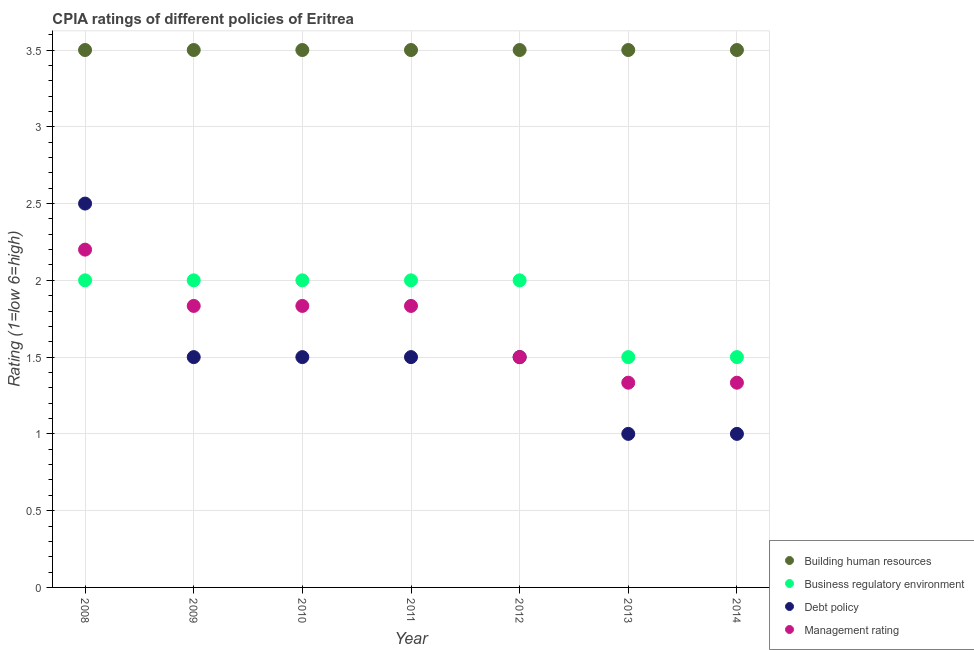Is the number of dotlines equal to the number of legend labels?
Offer a very short reply. Yes. Across all years, what is the maximum cpia rating of management?
Keep it short and to the point. 2.2. Across all years, what is the minimum cpia rating of business regulatory environment?
Your answer should be compact. 1.5. In which year was the cpia rating of building human resources minimum?
Your answer should be compact. 2008. What is the total cpia rating of building human resources in the graph?
Give a very brief answer. 24.5. What is the difference between the cpia rating of management in 2008 and that in 2011?
Give a very brief answer. 0.37. What is the average cpia rating of management per year?
Give a very brief answer. 1.7. In the year 2008, what is the difference between the cpia rating of building human resources and cpia rating of management?
Offer a terse response. 1.3. What is the ratio of the cpia rating of debt policy in 2008 to that in 2010?
Offer a terse response. 1.67. Is the difference between the cpia rating of business regulatory environment in 2012 and 2014 greater than the difference between the cpia rating of debt policy in 2012 and 2014?
Your answer should be compact. No. What is the difference between the highest and the lowest cpia rating of business regulatory environment?
Offer a terse response. 0.5. Is the sum of the cpia rating of management in 2010 and 2013 greater than the maximum cpia rating of business regulatory environment across all years?
Give a very brief answer. Yes. Is it the case that in every year, the sum of the cpia rating of building human resources and cpia rating of business regulatory environment is greater than the cpia rating of debt policy?
Your answer should be very brief. Yes. Is the cpia rating of debt policy strictly greater than the cpia rating of building human resources over the years?
Make the answer very short. No. Is the cpia rating of debt policy strictly less than the cpia rating of building human resources over the years?
Keep it short and to the point. Yes. How many dotlines are there?
Your answer should be very brief. 4. How many years are there in the graph?
Provide a short and direct response. 7. What is the difference between two consecutive major ticks on the Y-axis?
Offer a very short reply. 0.5. Are the values on the major ticks of Y-axis written in scientific E-notation?
Ensure brevity in your answer.  No. Where does the legend appear in the graph?
Offer a terse response. Bottom right. How are the legend labels stacked?
Offer a very short reply. Vertical. What is the title of the graph?
Give a very brief answer. CPIA ratings of different policies of Eritrea. Does "Pre-primary schools" appear as one of the legend labels in the graph?
Offer a terse response. No. What is the label or title of the X-axis?
Your answer should be compact. Year. What is the label or title of the Y-axis?
Your answer should be compact. Rating (1=low 6=high). What is the Rating (1=low 6=high) in Business regulatory environment in 2008?
Keep it short and to the point. 2. What is the Rating (1=low 6=high) in Debt policy in 2008?
Keep it short and to the point. 2.5. What is the Rating (1=low 6=high) in Management rating in 2008?
Keep it short and to the point. 2.2. What is the Rating (1=low 6=high) in Building human resources in 2009?
Offer a terse response. 3.5. What is the Rating (1=low 6=high) of Business regulatory environment in 2009?
Offer a terse response. 2. What is the Rating (1=low 6=high) in Management rating in 2009?
Provide a short and direct response. 1.83. What is the Rating (1=low 6=high) of Management rating in 2010?
Your answer should be compact. 1.83. What is the Rating (1=low 6=high) of Building human resources in 2011?
Your answer should be compact. 3.5. What is the Rating (1=low 6=high) in Management rating in 2011?
Make the answer very short. 1.83. What is the Rating (1=low 6=high) of Business regulatory environment in 2012?
Offer a very short reply. 2. What is the Rating (1=low 6=high) of Business regulatory environment in 2013?
Your answer should be compact. 1.5. What is the Rating (1=low 6=high) of Debt policy in 2013?
Your response must be concise. 1. What is the Rating (1=low 6=high) in Management rating in 2013?
Offer a terse response. 1.33. What is the Rating (1=low 6=high) of Debt policy in 2014?
Your response must be concise. 1. What is the Rating (1=low 6=high) in Management rating in 2014?
Your response must be concise. 1.33. Across all years, what is the maximum Rating (1=low 6=high) of Debt policy?
Keep it short and to the point. 2.5. Across all years, what is the minimum Rating (1=low 6=high) in Building human resources?
Your answer should be compact. 3.5. Across all years, what is the minimum Rating (1=low 6=high) of Business regulatory environment?
Provide a short and direct response. 1.5. Across all years, what is the minimum Rating (1=low 6=high) of Debt policy?
Provide a short and direct response. 1. Across all years, what is the minimum Rating (1=low 6=high) of Management rating?
Your response must be concise. 1.33. What is the total Rating (1=low 6=high) in Building human resources in the graph?
Keep it short and to the point. 24.5. What is the total Rating (1=low 6=high) of Debt policy in the graph?
Offer a very short reply. 10.5. What is the total Rating (1=low 6=high) in Management rating in the graph?
Your answer should be very brief. 11.87. What is the difference between the Rating (1=low 6=high) of Debt policy in 2008 and that in 2009?
Your answer should be compact. 1. What is the difference between the Rating (1=low 6=high) in Management rating in 2008 and that in 2009?
Offer a terse response. 0.37. What is the difference between the Rating (1=low 6=high) of Building human resources in 2008 and that in 2010?
Make the answer very short. 0. What is the difference between the Rating (1=low 6=high) in Debt policy in 2008 and that in 2010?
Your answer should be compact. 1. What is the difference between the Rating (1=low 6=high) of Management rating in 2008 and that in 2010?
Your response must be concise. 0.37. What is the difference between the Rating (1=low 6=high) in Building human resources in 2008 and that in 2011?
Offer a very short reply. 0. What is the difference between the Rating (1=low 6=high) of Management rating in 2008 and that in 2011?
Your response must be concise. 0.37. What is the difference between the Rating (1=low 6=high) of Building human resources in 2008 and that in 2012?
Your answer should be very brief. 0. What is the difference between the Rating (1=low 6=high) in Building human resources in 2008 and that in 2013?
Give a very brief answer. 0. What is the difference between the Rating (1=low 6=high) of Management rating in 2008 and that in 2013?
Offer a very short reply. 0.87. What is the difference between the Rating (1=low 6=high) of Building human resources in 2008 and that in 2014?
Make the answer very short. 0. What is the difference between the Rating (1=low 6=high) in Business regulatory environment in 2008 and that in 2014?
Provide a short and direct response. 0.5. What is the difference between the Rating (1=low 6=high) in Management rating in 2008 and that in 2014?
Your response must be concise. 0.87. What is the difference between the Rating (1=low 6=high) of Building human resources in 2009 and that in 2010?
Ensure brevity in your answer.  0. What is the difference between the Rating (1=low 6=high) in Business regulatory environment in 2009 and that in 2010?
Provide a short and direct response. 0. What is the difference between the Rating (1=low 6=high) of Management rating in 2009 and that in 2010?
Provide a short and direct response. 0. What is the difference between the Rating (1=low 6=high) of Management rating in 2009 and that in 2011?
Your answer should be very brief. 0. What is the difference between the Rating (1=low 6=high) in Debt policy in 2009 and that in 2012?
Offer a terse response. 0. What is the difference between the Rating (1=low 6=high) in Building human resources in 2009 and that in 2013?
Offer a very short reply. 0. What is the difference between the Rating (1=low 6=high) of Management rating in 2009 and that in 2013?
Give a very brief answer. 0.5. What is the difference between the Rating (1=low 6=high) in Building human resources in 2009 and that in 2014?
Give a very brief answer. 0. What is the difference between the Rating (1=low 6=high) of Business regulatory environment in 2009 and that in 2014?
Your answer should be compact. 0.5. What is the difference between the Rating (1=low 6=high) of Management rating in 2009 and that in 2014?
Provide a short and direct response. 0.5. What is the difference between the Rating (1=low 6=high) of Business regulatory environment in 2010 and that in 2011?
Make the answer very short. 0. What is the difference between the Rating (1=low 6=high) in Building human resources in 2010 and that in 2012?
Ensure brevity in your answer.  0. What is the difference between the Rating (1=low 6=high) in Business regulatory environment in 2010 and that in 2012?
Keep it short and to the point. 0. What is the difference between the Rating (1=low 6=high) of Management rating in 2010 and that in 2012?
Offer a terse response. 0.33. What is the difference between the Rating (1=low 6=high) of Building human resources in 2010 and that in 2013?
Offer a terse response. 0. What is the difference between the Rating (1=low 6=high) of Debt policy in 2010 and that in 2013?
Provide a short and direct response. 0.5. What is the difference between the Rating (1=low 6=high) of Management rating in 2010 and that in 2013?
Offer a very short reply. 0.5. What is the difference between the Rating (1=low 6=high) in Management rating in 2010 and that in 2014?
Provide a short and direct response. 0.5. What is the difference between the Rating (1=low 6=high) in Building human resources in 2011 and that in 2012?
Your answer should be compact. 0. What is the difference between the Rating (1=low 6=high) of Management rating in 2011 and that in 2013?
Offer a very short reply. 0.5. What is the difference between the Rating (1=low 6=high) in Business regulatory environment in 2011 and that in 2014?
Ensure brevity in your answer.  0.5. What is the difference between the Rating (1=low 6=high) in Management rating in 2011 and that in 2014?
Your answer should be compact. 0.5. What is the difference between the Rating (1=low 6=high) of Business regulatory environment in 2012 and that in 2013?
Provide a succinct answer. 0.5. What is the difference between the Rating (1=low 6=high) of Debt policy in 2012 and that in 2013?
Your answer should be very brief. 0.5. What is the difference between the Rating (1=low 6=high) in Building human resources in 2012 and that in 2014?
Your answer should be very brief. 0. What is the difference between the Rating (1=low 6=high) of Business regulatory environment in 2012 and that in 2014?
Ensure brevity in your answer.  0.5. What is the difference between the Rating (1=low 6=high) in Debt policy in 2012 and that in 2014?
Provide a short and direct response. 0.5. What is the difference between the Rating (1=low 6=high) in Management rating in 2012 and that in 2014?
Provide a short and direct response. 0.17. What is the difference between the Rating (1=low 6=high) in Business regulatory environment in 2013 and that in 2014?
Your response must be concise. 0. What is the difference between the Rating (1=low 6=high) in Building human resources in 2008 and the Rating (1=low 6=high) in Business regulatory environment in 2009?
Give a very brief answer. 1.5. What is the difference between the Rating (1=low 6=high) of Building human resources in 2008 and the Rating (1=low 6=high) of Management rating in 2009?
Keep it short and to the point. 1.67. What is the difference between the Rating (1=low 6=high) of Business regulatory environment in 2008 and the Rating (1=low 6=high) of Debt policy in 2009?
Make the answer very short. 0.5. What is the difference between the Rating (1=low 6=high) of Building human resources in 2008 and the Rating (1=low 6=high) of Business regulatory environment in 2010?
Provide a short and direct response. 1.5. What is the difference between the Rating (1=low 6=high) of Business regulatory environment in 2008 and the Rating (1=low 6=high) of Debt policy in 2010?
Keep it short and to the point. 0.5. What is the difference between the Rating (1=low 6=high) of Business regulatory environment in 2008 and the Rating (1=low 6=high) of Management rating in 2010?
Make the answer very short. 0.17. What is the difference between the Rating (1=low 6=high) in Debt policy in 2008 and the Rating (1=low 6=high) in Management rating in 2010?
Keep it short and to the point. 0.67. What is the difference between the Rating (1=low 6=high) of Building human resources in 2008 and the Rating (1=low 6=high) of Debt policy in 2011?
Your answer should be compact. 2. What is the difference between the Rating (1=low 6=high) of Building human resources in 2008 and the Rating (1=low 6=high) of Management rating in 2011?
Keep it short and to the point. 1.67. What is the difference between the Rating (1=low 6=high) in Business regulatory environment in 2008 and the Rating (1=low 6=high) in Debt policy in 2011?
Offer a very short reply. 0.5. What is the difference between the Rating (1=low 6=high) of Business regulatory environment in 2008 and the Rating (1=low 6=high) of Management rating in 2011?
Ensure brevity in your answer.  0.17. What is the difference between the Rating (1=low 6=high) in Building human resources in 2008 and the Rating (1=low 6=high) in Business regulatory environment in 2012?
Offer a terse response. 1.5. What is the difference between the Rating (1=low 6=high) in Building human resources in 2008 and the Rating (1=low 6=high) in Debt policy in 2012?
Ensure brevity in your answer.  2. What is the difference between the Rating (1=low 6=high) of Building human resources in 2008 and the Rating (1=low 6=high) of Management rating in 2012?
Your response must be concise. 2. What is the difference between the Rating (1=low 6=high) in Business regulatory environment in 2008 and the Rating (1=low 6=high) in Debt policy in 2012?
Keep it short and to the point. 0.5. What is the difference between the Rating (1=low 6=high) of Building human resources in 2008 and the Rating (1=low 6=high) of Business regulatory environment in 2013?
Provide a short and direct response. 2. What is the difference between the Rating (1=low 6=high) of Building human resources in 2008 and the Rating (1=low 6=high) of Debt policy in 2013?
Provide a succinct answer. 2.5. What is the difference between the Rating (1=low 6=high) in Building human resources in 2008 and the Rating (1=low 6=high) in Management rating in 2013?
Offer a terse response. 2.17. What is the difference between the Rating (1=low 6=high) of Building human resources in 2008 and the Rating (1=low 6=high) of Debt policy in 2014?
Your answer should be very brief. 2.5. What is the difference between the Rating (1=low 6=high) of Building human resources in 2008 and the Rating (1=low 6=high) of Management rating in 2014?
Your answer should be very brief. 2.17. What is the difference between the Rating (1=low 6=high) in Debt policy in 2008 and the Rating (1=low 6=high) in Management rating in 2014?
Your answer should be very brief. 1.17. What is the difference between the Rating (1=low 6=high) of Building human resources in 2009 and the Rating (1=low 6=high) of Business regulatory environment in 2010?
Provide a short and direct response. 1.5. What is the difference between the Rating (1=low 6=high) in Building human resources in 2009 and the Rating (1=low 6=high) in Debt policy in 2010?
Give a very brief answer. 2. What is the difference between the Rating (1=low 6=high) of Building human resources in 2009 and the Rating (1=low 6=high) of Management rating in 2010?
Provide a short and direct response. 1.67. What is the difference between the Rating (1=low 6=high) of Business regulatory environment in 2009 and the Rating (1=low 6=high) of Debt policy in 2010?
Your response must be concise. 0.5. What is the difference between the Rating (1=low 6=high) of Business regulatory environment in 2009 and the Rating (1=low 6=high) of Management rating in 2010?
Provide a short and direct response. 0.17. What is the difference between the Rating (1=low 6=high) in Debt policy in 2009 and the Rating (1=low 6=high) in Management rating in 2010?
Offer a terse response. -0.33. What is the difference between the Rating (1=low 6=high) of Building human resources in 2009 and the Rating (1=low 6=high) of Debt policy in 2011?
Ensure brevity in your answer.  2. What is the difference between the Rating (1=low 6=high) in Building human resources in 2009 and the Rating (1=low 6=high) in Management rating in 2011?
Provide a short and direct response. 1.67. What is the difference between the Rating (1=low 6=high) in Debt policy in 2009 and the Rating (1=low 6=high) in Management rating in 2011?
Your answer should be very brief. -0.33. What is the difference between the Rating (1=low 6=high) in Building human resources in 2009 and the Rating (1=low 6=high) in Business regulatory environment in 2012?
Ensure brevity in your answer.  1.5. What is the difference between the Rating (1=low 6=high) in Business regulatory environment in 2009 and the Rating (1=low 6=high) in Management rating in 2012?
Offer a very short reply. 0.5. What is the difference between the Rating (1=low 6=high) of Debt policy in 2009 and the Rating (1=low 6=high) of Management rating in 2012?
Make the answer very short. 0. What is the difference between the Rating (1=low 6=high) of Building human resources in 2009 and the Rating (1=low 6=high) of Management rating in 2013?
Provide a short and direct response. 2.17. What is the difference between the Rating (1=low 6=high) in Business regulatory environment in 2009 and the Rating (1=low 6=high) in Debt policy in 2013?
Provide a succinct answer. 1. What is the difference between the Rating (1=low 6=high) in Business regulatory environment in 2009 and the Rating (1=low 6=high) in Management rating in 2013?
Give a very brief answer. 0.67. What is the difference between the Rating (1=low 6=high) in Debt policy in 2009 and the Rating (1=low 6=high) in Management rating in 2013?
Give a very brief answer. 0.17. What is the difference between the Rating (1=low 6=high) of Building human resources in 2009 and the Rating (1=low 6=high) of Business regulatory environment in 2014?
Your answer should be very brief. 2. What is the difference between the Rating (1=low 6=high) in Building human resources in 2009 and the Rating (1=low 6=high) in Debt policy in 2014?
Keep it short and to the point. 2.5. What is the difference between the Rating (1=low 6=high) in Building human resources in 2009 and the Rating (1=low 6=high) in Management rating in 2014?
Make the answer very short. 2.17. What is the difference between the Rating (1=low 6=high) in Building human resources in 2010 and the Rating (1=low 6=high) in Business regulatory environment in 2011?
Make the answer very short. 1.5. What is the difference between the Rating (1=low 6=high) of Business regulatory environment in 2010 and the Rating (1=low 6=high) of Debt policy in 2011?
Offer a terse response. 0.5. What is the difference between the Rating (1=low 6=high) in Building human resources in 2010 and the Rating (1=low 6=high) in Debt policy in 2012?
Your response must be concise. 2. What is the difference between the Rating (1=low 6=high) of Business regulatory environment in 2010 and the Rating (1=low 6=high) of Management rating in 2012?
Give a very brief answer. 0.5. What is the difference between the Rating (1=low 6=high) in Debt policy in 2010 and the Rating (1=low 6=high) in Management rating in 2012?
Give a very brief answer. 0. What is the difference between the Rating (1=low 6=high) in Building human resources in 2010 and the Rating (1=low 6=high) in Business regulatory environment in 2013?
Give a very brief answer. 2. What is the difference between the Rating (1=low 6=high) in Building human resources in 2010 and the Rating (1=low 6=high) in Management rating in 2013?
Provide a succinct answer. 2.17. What is the difference between the Rating (1=low 6=high) of Business regulatory environment in 2010 and the Rating (1=low 6=high) of Management rating in 2013?
Provide a succinct answer. 0.67. What is the difference between the Rating (1=low 6=high) of Building human resources in 2010 and the Rating (1=low 6=high) of Debt policy in 2014?
Your answer should be compact. 2.5. What is the difference between the Rating (1=low 6=high) in Building human resources in 2010 and the Rating (1=low 6=high) in Management rating in 2014?
Your answer should be very brief. 2.17. What is the difference between the Rating (1=low 6=high) in Building human resources in 2011 and the Rating (1=low 6=high) in Debt policy in 2012?
Offer a terse response. 2. What is the difference between the Rating (1=low 6=high) in Debt policy in 2011 and the Rating (1=low 6=high) in Management rating in 2012?
Offer a very short reply. 0. What is the difference between the Rating (1=low 6=high) in Building human resources in 2011 and the Rating (1=low 6=high) in Management rating in 2013?
Keep it short and to the point. 2.17. What is the difference between the Rating (1=low 6=high) of Business regulatory environment in 2011 and the Rating (1=low 6=high) of Debt policy in 2013?
Give a very brief answer. 1. What is the difference between the Rating (1=low 6=high) of Debt policy in 2011 and the Rating (1=low 6=high) of Management rating in 2013?
Keep it short and to the point. 0.17. What is the difference between the Rating (1=low 6=high) in Building human resources in 2011 and the Rating (1=low 6=high) in Business regulatory environment in 2014?
Ensure brevity in your answer.  2. What is the difference between the Rating (1=low 6=high) in Building human resources in 2011 and the Rating (1=low 6=high) in Debt policy in 2014?
Provide a succinct answer. 2.5. What is the difference between the Rating (1=low 6=high) in Building human resources in 2011 and the Rating (1=low 6=high) in Management rating in 2014?
Provide a succinct answer. 2.17. What is the difference between the Rating (1=low 6=high) of Debt policy in 2011 and the Rating (1=low 6=high) of Management rating in 2014?
Your answer should be very brief. 0.17. What is the difference between the Rating (1=low 6=high) of Building human resources in 2012 and the Rating (1=low 6=high) of Management rating in 2013?
Offer a very short reply. 2.17. What is the difference between the Rating (1=low 6=high) of Business regulatory environment in 2012 and the Rating (1=low 6=high) of Debt policy in 2013?
Give a very brief answer. 1. What is the difference between the Rating (1=low 6=high) in Business regulatory environment in 2012 and the Rating (1=low 6=high) in Management rating in 2013?
Keep it short and to the point. 0.67. What is the difference between the Rating (1=low 6=high) of Debt policy in 2012 and the Rating (1=low 6=high) of Management rating in 2013?
Your answer should be compact. 0.17. What is the difference between the Rating (1=low 6=high) in Building human resources in 2012 and the Rating (1=low 6=high) in Business regulatory environment in 2014?
Your answer should be very brief. 2. What is the difference between the Rating (1=low 6=high) of Building human resources in 2012 and the Rating (1=low 6=high) of Debt policy in 2014?
Offer a very short reply. 2.5. What is the difference between the Rating (1=low 6=high) in Building human resources in 2012 and the Rating (1=low 6=high) in Management rating in 2014?
Keep it short and to the point. 2.17. What is the difference between the Rating (1=low 6=high) of Debt policy in 2012 and the Rating (1=low 6=high) of Management rating in 2014?
Provide a succinct answer. 0.17. What is the difference between the Rating (1=low 6=high) of Building human resources in 2013 and the Rating (1=low 6=high) of Debt policy in 2014?
Your response must be concise. 2.5. What is the difference between the Rating (1=low 6=high) in Building human resources in 2013 and the Rating (1=low 6=high) in Management rating in 2014?
Your answer should be very brief. 2.17. What is the average Rating (1=low 6=high) of Building human resources per year?
Provide a succinct answer. 3.5. What is the average Rating (1=low 6=high) of Business regulatory environment per year?
Your answer should be very brief. 1.86. What is the average Rating (1=low 6=high) of Management rating per year?
Offer a very short reply. 1.7. In the year 2008, what is the difference between the Rating (1=low 6=high) of Building human resources and Rating (1=low 6=high) of Business regulatory environment?
Provide a succinct answer. 1.5. In the year 2008, what is the difference between the Rating (1=low 6=high) in Building human resources and Rating (1=low 6=high) in Management rating?
Ensure brevity in your answer.  1.3. In the year 2008, what is the difference between the Rating (1=low 6=high) in Business regulatory environment and Rating (1=low 6=high) in Debt policy?
Offer a very short reply. -0.5. In the year 2008, what is the difference between the Rating (1=low 6=high) in Debt policy and Rating (1=low 6=high) in Management rating?
Your answer should be very brief. 0.3. In the year 2009, what is the difference between the Rating (1=low 6=high) of Building human resources and Rating (1=low 6=high) of Debt policy?
Provide a short and direct response. 2. In the year 2009, what is the difference between the Rating (1=low 6=high) of Business regulatory environment and Rating (1=low 6=high) of Management rating?
Ensure brevity in your answer.  0.17. In the year 2010, what is the difference between the Rating (1=low 6=high) in Business regulatory environment and Rating (1=low 6=high) in Management rating?
Your answer should be very brief. 0.17. In the year 2011, what is the difference between the Rating (1=low 6=high) in Building human resources and Rating (1=low 6=high) in Debt policy?
Your answer should be very brief. 2. In the year 2011, what is the difference between the Rating (1=low 6=high) in Business regulatory environment and Rating (1=low 6=high) in Debt policy?
Provide a short and direct response. 0.5. In the year 2011, what is the difference between the Rating (1=low 6=high) in Business regulatory environment and Rating (1=low 6=high) in Management rating?
Keep it short and to the point. 0.17. In the year 2011, what is the difference between the Rating (1=low 6=high) in Debt policy and Rating (1=low 6=high) in Management rating?
Offer a very short reply. -0.33. In the year 2013, what is the difference between the Rating (1=low 6=high) in Building human resources and Rating (1=low 6=high) in Debt policy?
Your answer should be very brief. 2.5. In the year 2013, what is the difference between the Rating (1=low 6=high) in Building human resources and Rating (1=low 6=high) in Management rating?
Offer a terse response. 2.17. In the year 2013, what is the difference between the Rating (1=low 6=high) in Business regulatory environment and Rating (1=low 6=high) in Debt policy?
Offer a terse response. 0.5. In the year 2013, what is the difference between the Rating (1=low 6=high) in Debt policy and Rating (1=low 6=high) in Management rating?
Keep it short and to the point. -0.33. In the year 2014, what is the difference between the Rating (1=low 6=high) of Building human resources and Rating (1=low 6=high) of Business regulatory environment?
Your response must be concise. 2. In the year 2014, what is the difference between the Rating (1=low 6=high) in Building human resources and Rating (1=low 6=high) in Management rating?
Your answer should be compact. 2.17. In the year 2014, what is the difference between the Rating (1=low 6=high) of Business regulatory environment and Rating (1=low 6=high) of Management rating?
Provide a succinct answer. 0.17. What is the ratio of the Rating (1=low 6=high) of Debt policy in 2008 to that in 2009?
Ensure brevity in your answer.  1.67. What is the ratio of the Rating (1=low 6=high) in Building human resources in 2008 to that in 2010?
Offer a very short reply. 1. What is the ratio of the Rating (1=low 6=high) in Business regulatory environment in 2008 to that in 2010?
Make the answer very short. 1. What is the ratio of the Rating (1=low 6=high) in Debt policy in 2008 to that in 2010?
Give a very brief answer. 1.67. What is the ratio of the Rating (1=low 6=high) of Debt policy in 2008 to that in 2011?
Ensure brevity in your answer.  1.67. What is the ratio of the Rating (1=low 6=high) of Management rating in 2008 to that in 2012?
Keep it short and to the point. 1.47. What is the ratio of the Rating (1=low 6=high) in Business regulatory environment in 2008 to that in 2013?
Offer a very short reply. 1.33. What is the ratio of the Rating (1=low 6=high) of Debt policy in 2008 to that in 2013?
Offer a very short reply. 2.5. What is the ratio of the Rating (1=low 6=high) in Management rating in 2008 to that in 2013?
Offer a terse response. 1.65. What is the ratio of the Rating (1=low 6=high) in Business regulatory environment in 2008 to that in 2014?
Your response must be concise. 1.33. What is the ratio of the Rating (1=low 6=high) of Debt policy in 2008 to that in 2014?
Provide a short and direct response. 2.5. What is the ratio of the Rating (1=low 6=high) in Management rating in 2008 to that in 2014?
Ensure brevity in your answer.  1.65. What is the ratio of the Rating (1=low 6=high) in Building human resources in 2009 to that in 2010?
Ensure brevity in your answer.  1. What is the ratio of the Rating (1=low 6=high) of Business regulatory environment in 2009 to that in 2010?
Your response must be concise. 1. What is the ratio of the Rating (1=low 6=high) in Management rating in 2009 to that in 2010?
Give a very brief answer. 1. What is the ratio of the Rating (1=low 6=high) of Business regulatory environment in 2009 to that in 2011?
Offer a very short reply. 1. What is the ratio of the Rating (1=low 6=high) in Business regulatory environment in 2009 to that in 2012?
Your response must be concise. 1. What is the ratio of the Rating (1=low 6=high) of Debt policy in 2009 to that in 2012?
Give a very brief answer. 1. What is the ratio of the Rating (1=low 6=high) in Management rating in 2009 to that in 2012?
Provide a short and direct response. 1.22. What is the ratio of the Rating (1=low 6=high) in Management rating in 2009 to that in 2013?
Your response must be concise. 1.38. What is the ratio of the Rating (1=low 6=high) in Debt policy in 2009 to that in 2014?
Provide a succinct answer. 1.5. What is the ratio of the Rating (1=low 6=high) of Management rating in 2009 to that in 2014?
Your response must be concise. 1.38. What is the ratio of the Rating (1=low 6=high) of Building human resources in 2010 to that in 2011?
Your answer should be very brief. 1. What is the ratio of the Rating (1=low 6=high) of Management rating in 2010 to that in 2011?
Provide a succinct answer. 1. What is the ratio of the Rating (1=low 6=high) of Building human resources in 2010 to that in 2012?
Ensure brevity in your answer.  1. What is the ratio of the Rating (1=low 6=high) in Business regulatory environment in 2010 to that in 2012?
Your response must be concise. 1. What is the ratio of the Rating (1=low 6=high) in Management rating in 2010 to that in 2012?
Your answer should be very brief. 1.22. What is the ratio of the Rating (1=low 6=high) in Building human resources in 2010 to that in 2013?
Make the answer very short. 1. What is the ratio of the Rating (1=low 6=high) of Management rating in 2010 to that in 2013?
Make the answer very short. 1.38. What is the ratio of the Rating (1=low 6=high) in Building human resources in 2010 to that in 2014?
Give a very brief answer. 1. What is the ratio of the Rating (1=low 6=high) of Business regulatory environment in 2010 to that in 2014?
Your answer should be very brief. 1.33. What is the ratio of the Rating (1=low 6=high) of Debt policy in 2010 to that in 2014?
Your answer should be very brief. 1.5. What is the ratio of the Rating (1=low 6=high) in Management rating in 2010 to that in 2014?
Make the answer very short. 1.38. What is the ratio of the Rating (1=low 6=high) in Business regulatory environment in 2011 to that in 2012?
Keep it short and to the point. 1. What is the ratio of the Rating (1=low 6=high) in Management rating in 2011 to that in 2012?
Give a very brief answer. 1.22. What is the ratio of the Rating (1=low 6=high) in Building human resources in 2011 to that in 2013?
Make the answer very short. 1. What is the ratio of the Rating (1=low 6=high) in Debt policy in 2011 to that in 2013?
Keep it short and to the point. 1.5. What is the ratio of the Rating (1=low 6=high) in Management rating in 2011 to that in 2013?
Ensure brevity in your answer.  1.38. What is the ratio of the Rating (1=low 6=high) in Debt policy in 2011 to that in 2014?
Make the answer very short. 1.5. What is the ratio of the Rating (1=low 6=high) of Management rating in 2011 to that in 2014?
Your answer should be very brief. 1.38. What is the ratio of the Rating (1=low 6=high) in Building human resources in 2012 to that in 2013?
Make the answer very short. 1. What is the ratio of the Rating (1=low 6=high) of Business regulatory environment in 2012 to that in 2013?
Your response must be concise. 1.33. What is the ratio of the Rating (1=low 6=high) in Debt policy in 2012 to that in 2013?
Provide a succinct answer. 1.5. What is the ratio of the Rating (1=low 6=high) in Management rating in 2012 to that in 2013?
Your response must be concise. 1.12. What is the ratio of the Rating (1=low 6=high) of Building human resources in 2012 to that in 2014?
Offer a terse response. 1. What is the ratio of the Rating (1=low 6=high) of Building human resources in 2013 to that in 2014?
Provide a succinct answer. 1. What is the ratio of the Rating (1=low 6=high) in Business regulatory environment in 2013 to that in 2014?
Ensure brevity in your answer.  1. What is the ratio of the Rating (1=low 6=high) in Debt policy in 2013 to that in 2014?
Your response must be concise. 1. What is the ratio of the Rating (1=low 6=high) in Management rating in 2013 to that in 2014?
Offer a very short reply. 1. What is the difference between the highest and the second highest Rating (1=low 6=high) of Building human resources?
Make the answer very short. 0. What is the difference between the highest and the second highest Rating (1=low 6=high) of Business regulatory environment?
Your response must be concise. 0. What is the difference between the highest and the second highest Rating (1=low 6=high) of Debt policy?
Your response must be concise. 1. What is the difference between the highest and the second highest Rating (1=low 6=high) of Management rating?
Your response must be concise. 0.37. What is the difference between the highest and the lowest Rating (1=low 6=high) in Building human resources?
Your answer should be compact. 0. What is the difference between the highest and the lowest Rating (1=low 6=high) of Business regulatory environment?
Your response must be concise. 0.5. What is the difference between the highest and the lowest Rating (1=low 6=high) in Management rating?
Provide a short and direct response. 0.87. 